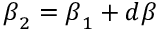<formula> <loc_0><loc_0><loc_500><loc_500>{ \beta } _ { 2 } = { \beta } _ { 1 } + d { \beta }</formula> 